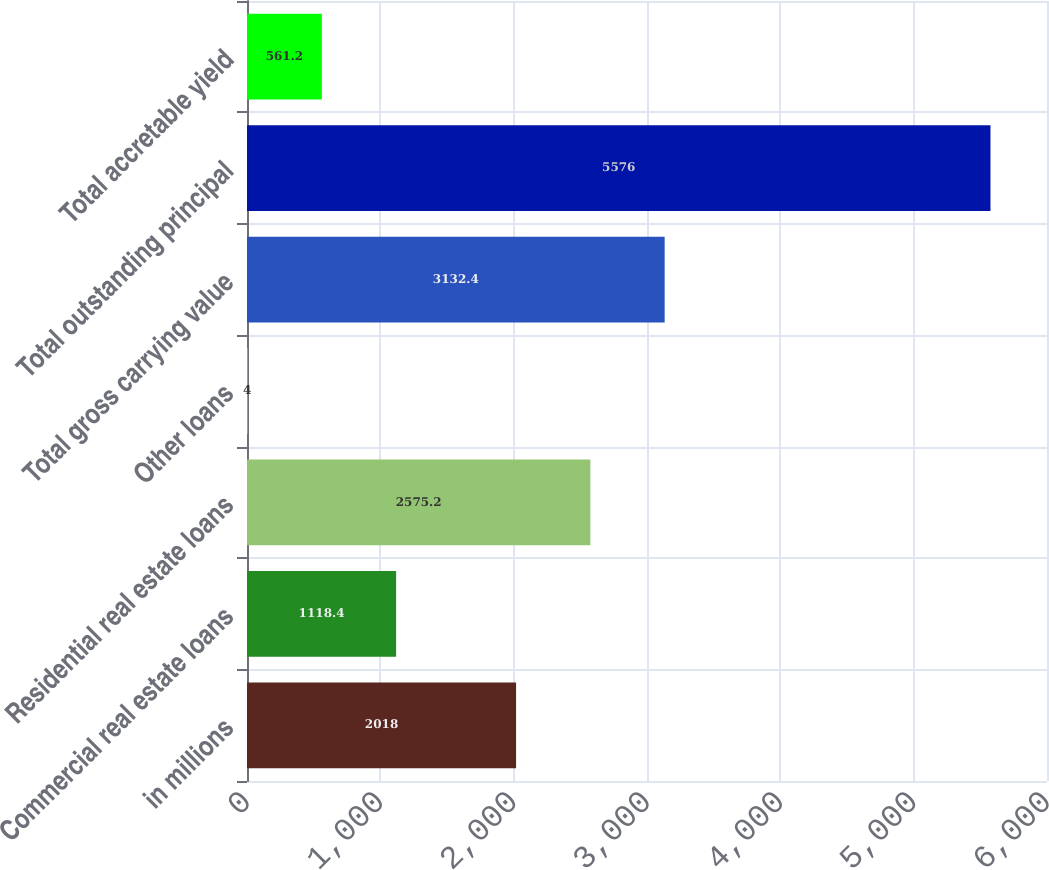<chart> <loc_0><loc_0><loc_500><loc_500><bar_chart><fcel>in millions<fcel>Commercial real estate loans<fcel>Residential real estate loans<fcel>Other loans<fcel>Total gross carrying value<fcel>Total outstanding principal<fcel>Total accretable yield<nl><fcel>2018<fcel>1118.4<fcel>2575.2<fcel>4<fcel>3132.4<fcel>5576<fcel>561.2<nl></chart> 